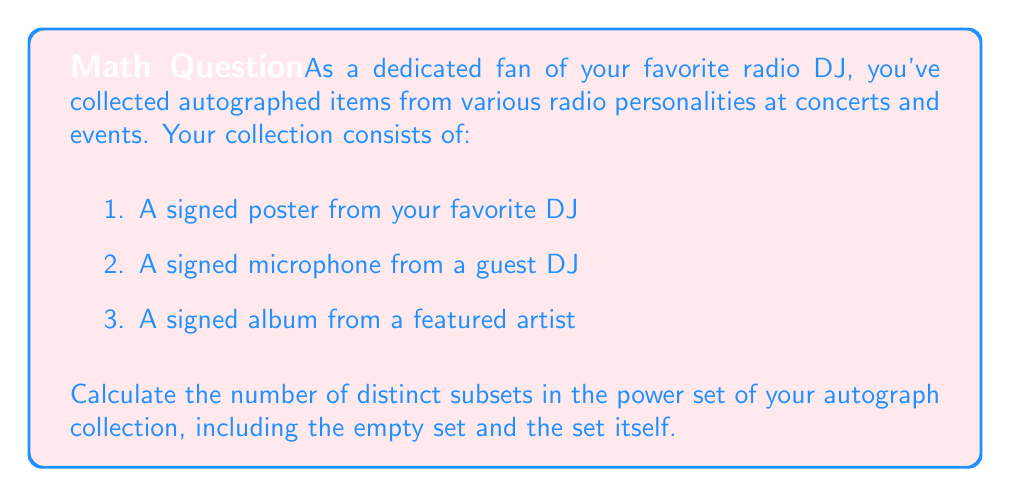Can you solve this math problem? To solve this problem, we need to understand the concept of power sets and how to calculate their size.

1. First, let's define our set:
   Let $A = \{poster, microphone, album\}$

2. The power set of A, denoted as $P(A)$, is the set of all possible subsets of A, including the empty set $\emptyset$ and A itself.

3. For a set with $n$ elements, the number of subsets in its power set is given by the formula:

   $$ |P(A)| = 2^n $$

   Where $|P(A)|$ represents the cardinality (number of elements) of the power set of A.

4. In our case, the set A has 3 elements (n = 3).

5. Therefore, the number of subsets in the power set is:

   $$ |P(A)| = 2^3 = 8 $$

6. To verify, we can list all possible subsets:
   - $\emptyset$ (empty set)
   - $\{poster\}$
   - $\{microphone\}$
   - $\{album\}$
   - $\{poster, microphone\}$
   - $\{poster, album\}$
   - $\{microphone, album\}$
   - $\{poster, microphone, album\}$

   Indeed, there are 8 subsets in total.
Answer: The number of distinct subsets in the power set of your autograph collection is $2^3 = 8$. 